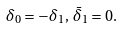<formula> <loc_0><loc_0><loc_500><loc_500>\delta _ { 0 } = - \delta _ { 1 } , \, \bar { \delta } _ { 1 } = 0 .</formula> 